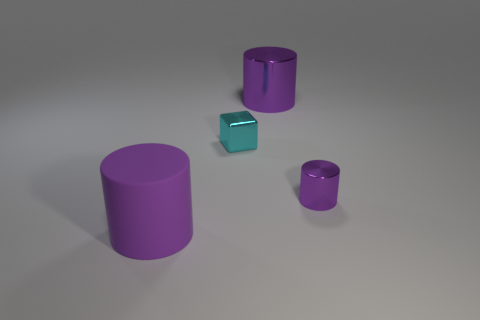Add 2 large shiny objects. How many objects exist? 6 Subtract all cylinders. How many objects are left? 1 Subtract 0 cyan balls. How many objects are left? 4 Subtract all large spheres. Subtract all big purple matte cylinders. How many objects are left? 3 Add 3 small cyan objects. How many small cyan objects are left? 4 Add 1 tiny metal cylinders. How many tiny metal cylinders exist? 2 